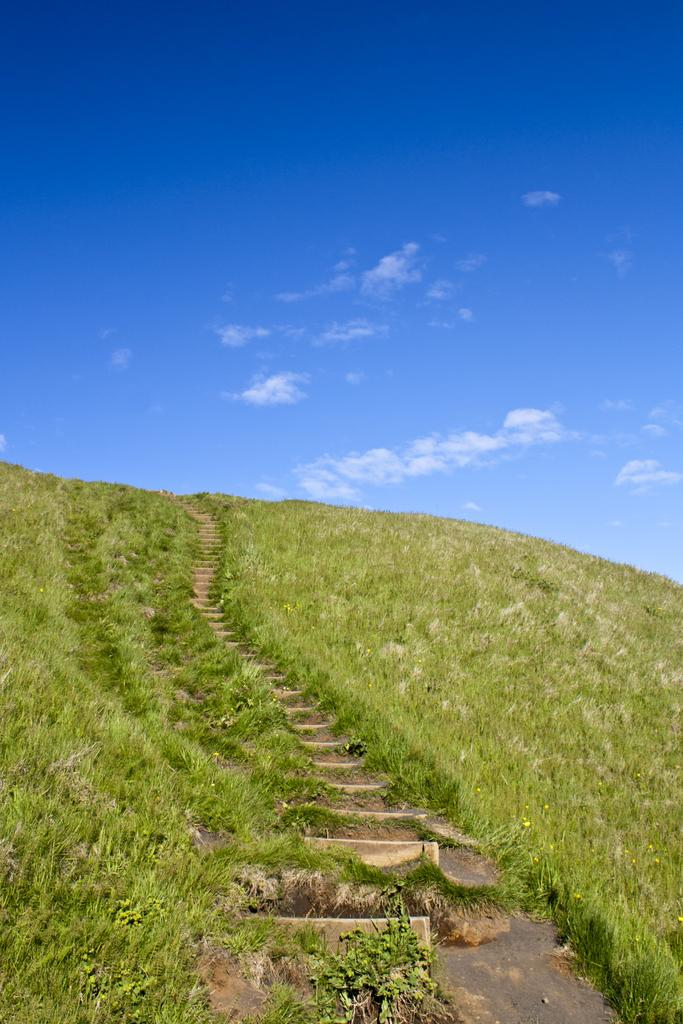What type of vegetation is present in the image? There is grass in the image. What architectural feature can be seen in the image? There are stairs in the image. What can be seen in the background of the image? There are clouds and the sky visible in the background of the image. What type of brush is used to clean the stairs in the image? There is no brush present in the image, and the stairs are not being cleaned. Is there a prison visible in the image? No, there is no prison present in the image. 